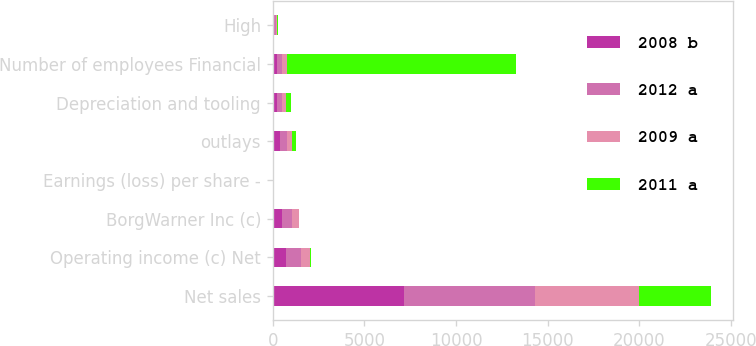Convert chart. <chart><loc_0><loc_0><loc_500><loc_500><stacked_bar_chart><ecel><fcel>Net sales<fcel>Operating income (c) Net<fcel>BorgWarner Inc (c)<fcel>Earnings (loss) per share -<fcel>outlays<fcel>Depreciation and tooling<fcel>Number of employees Financial<fcel>High<nl><fcel>2008 b<fcel>7183.2<fcel>752.9<fcel>500.9<fcel>4.45<fcel>407.4<fcel>260.2<fcel>260.2<fcel>87.45<nl><fcel>2012 a<fcel>7114.7<fcel>797.5<fcel>550.1<fcel>5.04<fcel>393.7<fcel>252.2<fcel>260.2<fcel>82.28<nl><fcel>2009 a<fcel>5652.8<fcel>504.3<fcel>377.4<fcel>3.31<fcel>276.6<fcel>224.5<fcel>260.2<fcel>73.43<nl><fcel>2011 a<fcel>3961.8<fcel>50.8<fcel>27<fcel>0.23<fcel>172<fcel>234.6<fcel>12500<fcel>36.78<nl></chart> 